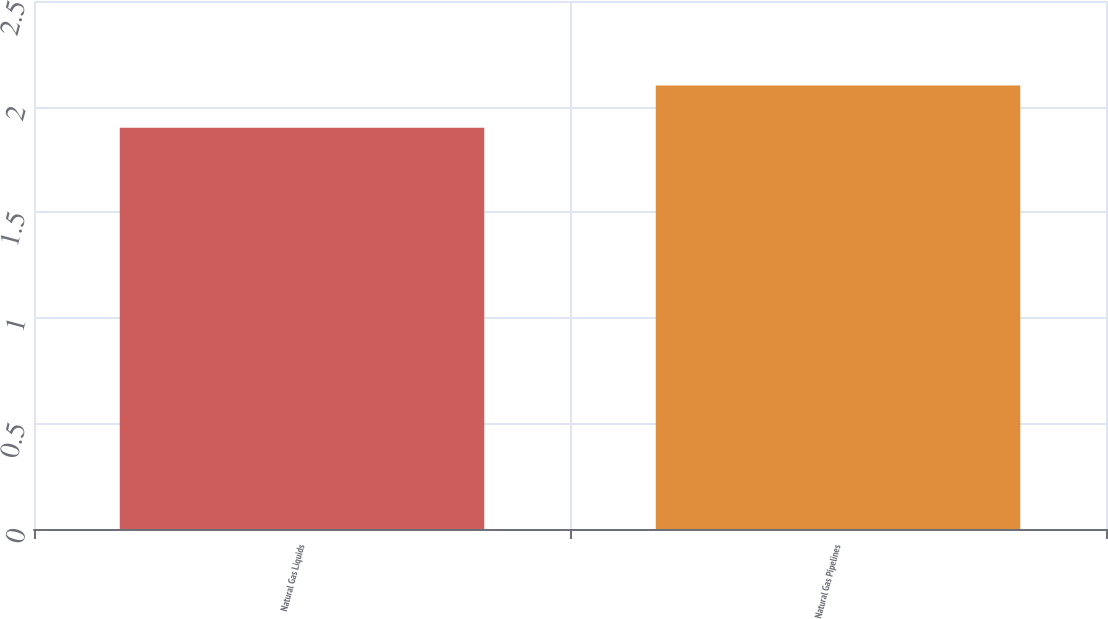Convert chart to OTSL. <chart><loc_0><loc_0><loc_500><loc_500><bar_chart><fcel>Natural Gas Liquids<fcel>Natural Gas Pipelines<nl><fcel>1.9<fcel>2.1<nl></chart> 